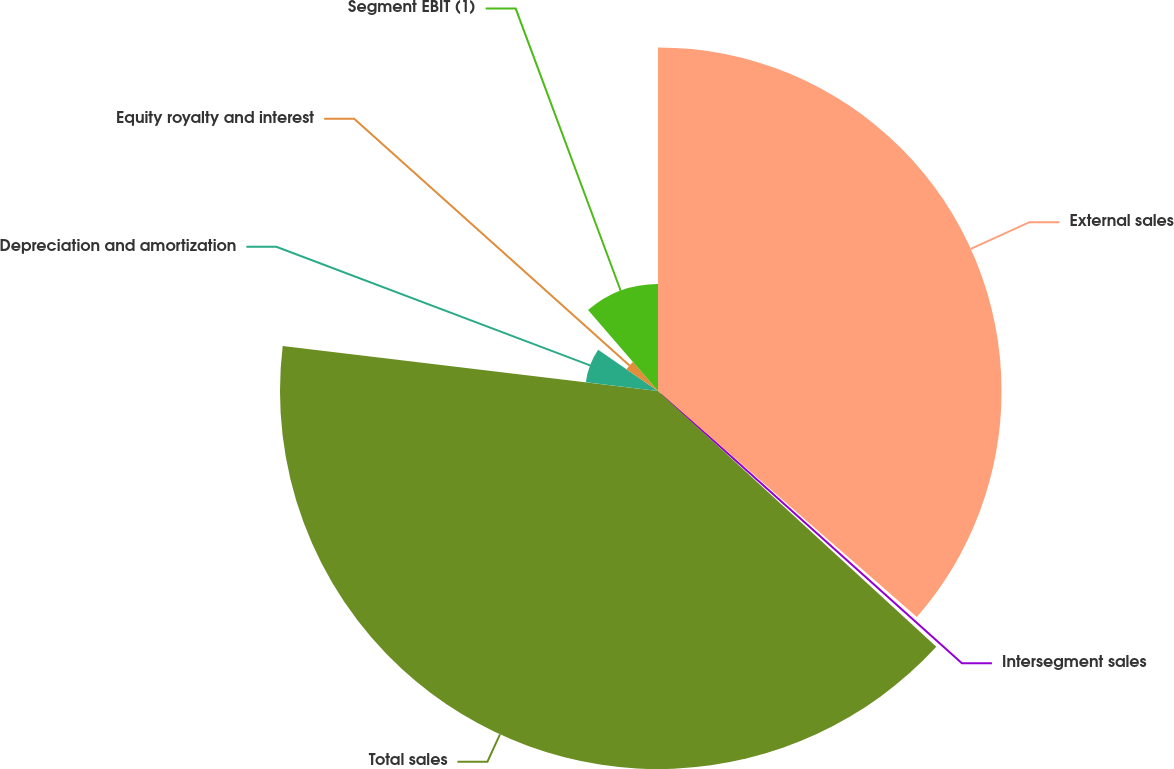Convert chart. <chart><loc_0><loc_0><loc_500><loc_500><pie_chart><fcel>External sales<fcel>Intersegment sales<fcel>Total sales<fcel>Depreciation and amortization<fcel>Equity royalty and interest<fcel>Segment EBIT (1)<nl><fcel>36.42%<fcel>0.41%<fcel>40.07%<fcel>7.7%<fcel>4.06%<fcel>11.34%<nl></chart> 